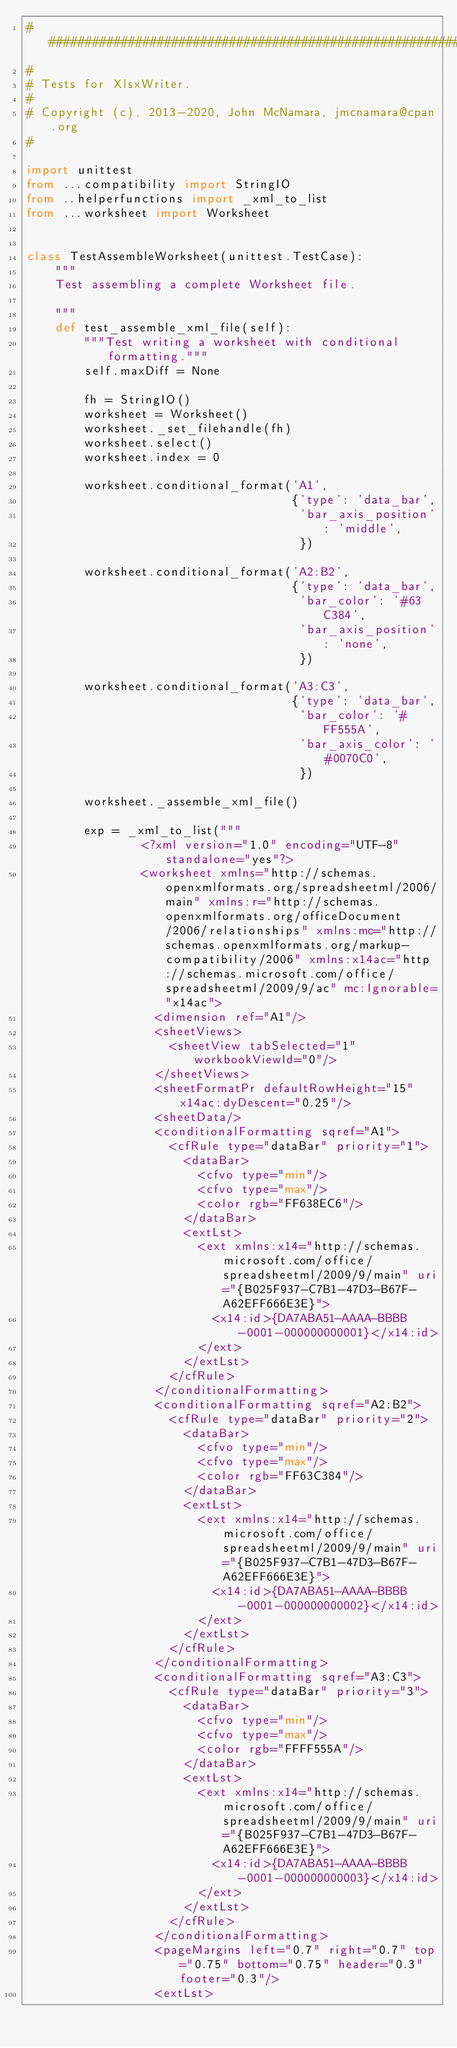Convert code to text. <code><loc_0><loc_0><loc_500><loc_500><_Python_>###############################################################################
#
# Tests for XlsxWriter.
#
# Copyright (c), 2013-2020, John McNamara, jmcnamara@cpan.org
#

import unittest
from ...compatibility import StringIO
from ..helperfunctions import _xml_to_list
from ...worksheet import Worksheet


class TestAssembleWorksheet(unittest.TestCase):
    """
    Test assembling a complete Worksheet file.

    """
    def test_assemble_xml_file(self):
        """Test writing a worksheet with conditional formatting."""
        self.maxDiff = None

        fh = StringIO()
        worksheet = Worksheet()
        worksheet._set_filehandle(fh)
        worksheet.select()
        worksheet.index = 0

        worksheet.conditional_format('A1',
                                     {'type': 'data_bar',
                                      'bar_axis_position': 'middle',
                                      })

        worksheet.conditional_format('A2:B2',
                                     {'type': 'data_bar',
                                      'bar_color': '#63C384',
                                      'bar_axis_position': 'none',
                                      })

        worksheet.conditional_format('A3:C3',
                                     {'type': 'data_bar',
                                      'bar_color': '#FF555A',
                                      'bar_axis_color': '#0070C0',
                                      })

        worksheet._assemble_xml_file()

        exp = _xml_to_list("""
                <?xml version="1.0" encoding="UTF-8" standalone="yes"?>
                <worksheet xmlns="http://schemas.openxmlformats.org/spreadsheetml/2006/main" xmlns:r="http://schemas.openxmlformats.org/officeDocument/2006/relationships" xmlns:mc="http://schemas.openxmlformats.org/markup-compatibility/2006" xmlns:x14ac="http://schemas.microsoft.com/office/spreadsheetml/2009/9/ac" mc:Ignorable="x14ac">
                  <dimension ref="A1"/>
                  <sheetViews>
                    <sheetView tabSelected="1" workbookViewId="0"/>
                  </sheetViews>
                  <sheetFormatPr defaultRowHeight="15" x14ac:dyDescent="0.25"/>
                  <sheetData/>
                  <conditionalFormatting sqref="A1">
                    <cfRule type="dataBar" priority="1">
                      <dataBar>
                        <cfvo type="min"/>
                        <cfvo type="max"/>
                        <color rgb="FF638EC6"/>
                      </dataBar>
                      <extLst>
                        <ext xmlns:x14="http://schemas.microsoft.com/office/spreadsheetml/2009/9/main" uri="{B025F937-C7B1-47D3-B67F-A62EFF666E3E}">
                          <x14:id>{DA7ABA51-AAAA-BBBB-0001-000000000001}</x14:id>
                        </ext>
                      </extLst>
                    </cfRule>
                  </conditionalFormatting>
                  <conditionalFormatting sqref="A2:B2">
                    <cfRule type="dataBar" priority="2">
                      <dataBar>
                        <cfvo type="min"/>
                        <cfvo type="max"/>
                        <color rgb="FF63C384"/>
                      </dataBar>
                      <extLst>
                        <ext xmlns:x14="http://schemas.microsoft.com/office/spreadsheetml/2009/9/main" uri="{B025F937-C7B1-47D3-B67F-A62EFF666E3E}">
                          <x14:id>{DA7ABA51-AAAA-BBBB-0001-000000000002}</x14:id>
                        </ext>
                      </extLst>
                    </cfRule>
                  </conditionalFormatting>
                  <conditionalFormatting sqref="A3:C3">
                    <cfRule type="dataBar" priority="3">
                      <dataBar>
                        <cfvo type="min"/>
                        <cfvo type="max"/>
                        <color rgb="FFFF555A"/>
                      </dataBar>
                      <extLst>
                        <ext xmlns:x14="http://schemas.microsoft.com/office/spreadsheetml/2009/9/main" uri="{B025F937-C7B1-47D3-B67F-A62EFF666E3E}">
                          <x14:id>{DA7ABA51-AAAA-BBBB-0001-000000000003}</x14:id>
                        </ext>
                      </extLst>
                    </cfRule>
                  </conditionalFormatting>
                  <pageMargins left="0.7" right="0.7" top="0.75" bottom="0.75" header="0.3" footer="0.3"/>
                  <extLst></code> 